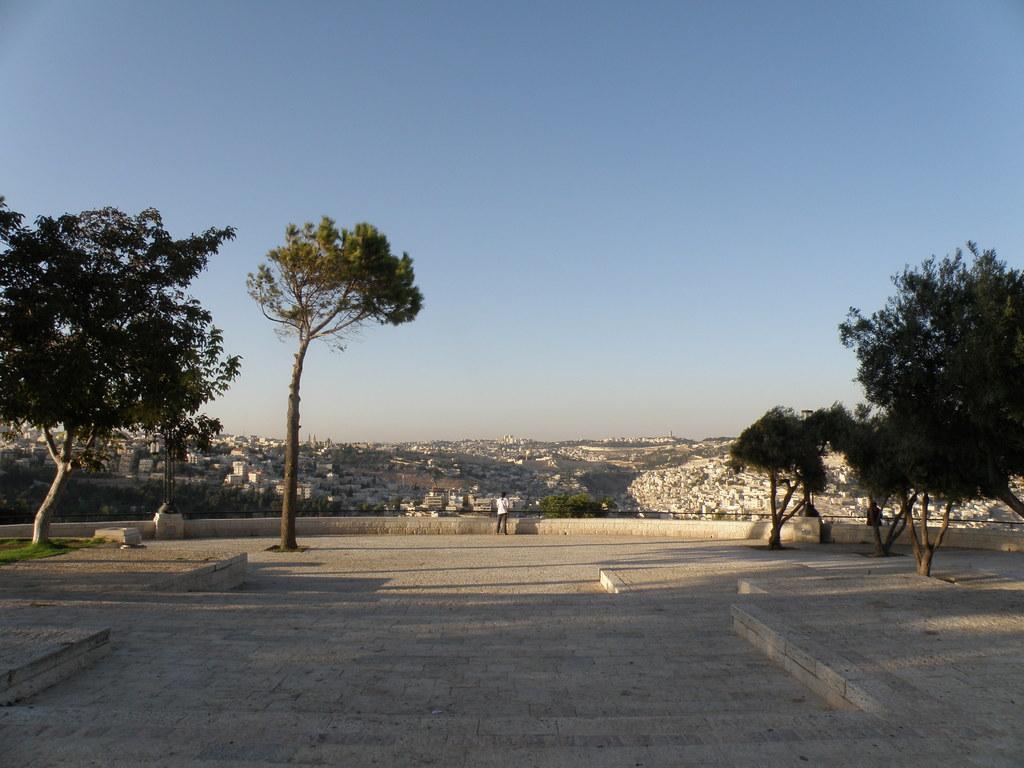How would you summarize this image in a sentence or two? In this image I can see the road. To the side there are trees. In the back I can see the person standing in-front of the wall. In the background there are few buildings and the sky. 